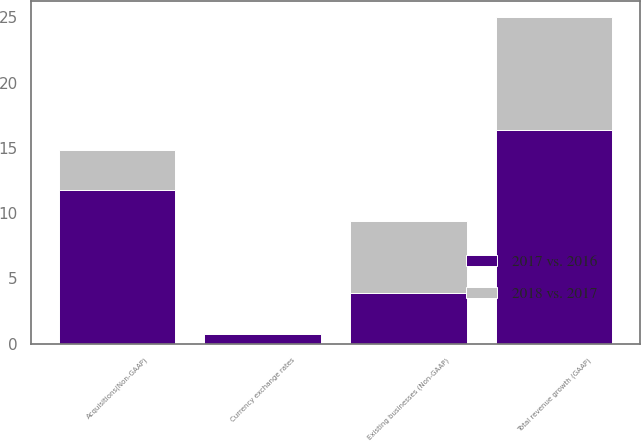<chart> <loc_0><loc_0><loc_500><loc_500><stacked_bar_chart><ecel><fcel>Total revenue growth (GAAP)<fcel>Existing businesses (Non-GAAP)<fcel>Acquisitions(Non-GAAP)<fcel>Currency exchange rates<nl><fcel>2017 vs. 2016<fcel>16.4<fcel>3.9<fcel>11.8<fcel>0.7<nl><fcel>2018 vs. 2017<fcel>8.6<fcel>5.5<fcel>3<fcel>0.1<nl></chart> 